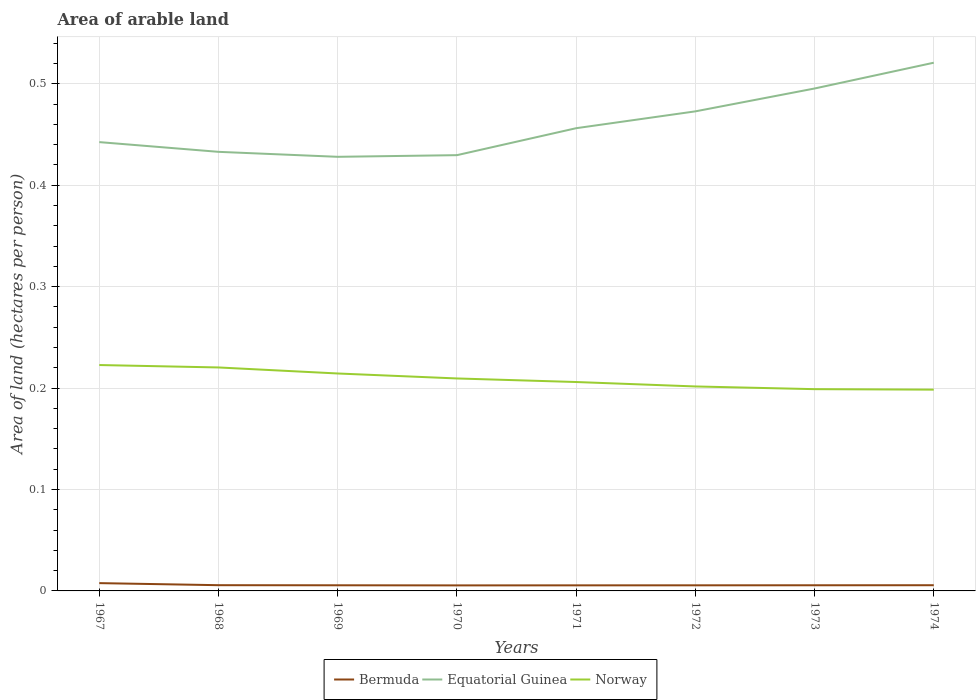How many different coloured lines are there?
Offer a very short reply. 3. Does the line corresponding to Norway intersect with the line corresponding to Equatorial Guinea?
Your answer should be compact. No. Across all years, what is the maximum total arable land in Norway?
Ensure brevity in your answer.  0.2. In which year was the total arable land in Equatorial Guinea maximum?
Offer a terse response. 1969. What is the total total arable land in Norway in the graph?
Offer a very short reply. 0.01. What is the difference between the highest and the second highest total arable land in Norway?
Your response must be concise. 0.02. Does the graph contain any zero values?
Make the answer very short. No. Does the graph contain grids?
Make the answer very short. Yes. How many legend labels are there?
Offer a very short reply. 3. How are the legend labels stacked?
Provide a succinct answer. Horizontal. What is the title of the graph?
Keep it short and to the point. Area of arable land. What is the label or title of the Y-axis?
Offer a terse response. Area of land (hectares per person). What is the Area of land (hectares per person) in Bermuda in 1967?
Provide a short and direct response. 0.01. What is the Area of land (hectares per person) of Equatorial Guinea in 1967?
Your answer should be very brief. 0.44. What is the Area of land (hectares per person) in Norway in 1967?
Keep it short and to the point. 0.22. What is the Area of land (hectares per person) in Bermuda in 1968?
Make the answer very short. 0.01. What is the Area of land (hectares per person) in Equatorial Guinea in 1968?
Offer a terse response. 0.43. What is the Area of land (hectares per person) of Norway in 1968?
Offer a terse response. 0.22. What is the Area of land (hectares per person) of Bermuda in 1969?
Offer a terse response. 0.01. What is the Area of land (hectares per person) of Equatorial Guinea in 1969?
Your answer should be compact. 0.43. What is the Area of land (hectares per person) of Norway in 1969?
Give a very brief answer. 0.21. What is the Area of land (hectares per person) in Bermuda in 1970?
Make the answer very short. 0.01. What is the Area of land (hectares per person) of Equatorial Guinea in 1970?
Provide a succinct answer. 0.43. What is the Area of land (hectares per person) of Norway in 1970?
Ensure brevity in your answer.  0.21. What is the Area of land (hectares per person) in Bermuda in 1971?
Give a very brief answer. 0.01. What is the Area of land (hectares per person) in Equatorial Guinea in 1971?
Provide a succinct answer. 0.46. What is the Area of land (hectares per person) of Norway in 1971?
Your response must be concise. 0.21. What is the Area of land (hectares per person) in Bermuda in 1972?
Keep it short and to the point. 0.01. What is the Area of land (hectares per person) in Equatorial Guinea in 1972?
Provide a succinct answer. 0.47. What is the Area of land (hectares per person) of Norway in 1972?
Ensure brevity in your answer.  0.2. What is the Area of land (hectares per person) in Bermuda in 1973?
Your answer should be very brief. 0.01. What is the Area of land (hectares per person) of Equatorial Guinea in 1973?
Keep it short and to the point. 0.5. What is the Area of land (hectares per person) of Norway in 1973?
Provide a short and direct response. 0.2. What is the Area of land (hectares per person) of Bermuda in 1974?
Provide a succinct answer. 0.01. What is the Area of land (hectares per person) of Equatorial Guinea in 1974?
Make the answer very short. 0.52. What is the Area of land (hectares per person) in Norway in 1974?
Your answer should be very brief. 0.2. Across all years, what is the maximum Area of land (hectares per person) in Bermuda?
Give a very brief answer. 0.01. Across all years, what is the maximum Area of land (hectares per person) of Equatorial Guinea?
Offer a terse response. 0.52. Across all years, what is the maximum Area of land (hectares per person) in Norway?
Provide a short and direct response. 0.22. Across all years, what is the minimum Area of land (hectares per person) in Bermuda?
Offer a terse response. 0.01. Across all years, what is the minimum Area of land (hectares per person) of Equatorial Guinea?
Provide a short and direct response. 0.43. Across all years, what is the minimum Area of land (hectares per person) of Norway?
Provide a succinct answer. 0.2. What is the total Area of land (hectares per person) of Bermuda in the graph?
Offer a terse response. 0.05. What is the total Area of land (hectares per person) of Equatorial Guinea in the graph?
Your answer should be very brief. 3.68. What is the total Area of land (hectares per person) of Norway in the graph?
Provide a short and direct response. 1.67. What is the difference between the Area of land (hectares per person) of Bermuda in 1967 and that in 1968?
Your answer should be very brief. 0. What is the difference between the Area of land (hectares per person) of Equatorial Guinea in 1967 and that in 1968?
Offer a very short reply. 0.01. What is the difference between the Area of land (hectares per person) of Norway in 1967 and that in 1968?
Your response must be concise. 0. What is the difference between the Area of land (hectares per person) in Bermuda in 1967 and that in 1969?
Provide a short and direct response. 0. What is the difference between the Area of land (hectares per person) in Equatorial Guinea in 1967 and that in 1969?
Give a very brief answer. 0.01. What is the difference between the Area of land (hectares per person) of Norway in 1967 and that in 1969?
Ensure brevity in your answer.  0.01. What is the difference between the Area of land (hectares per person) in Bermuda in 1967 and that in 1970?
Your answer should be very brief. 0. What is the difference between the Area of land (hectares per person) in Equatorial Guinea in 1967 and that in 1970?
Provide a succinct answer. 0.01. What is the difference between the Area of land (hectares per person) of Norway in 1967 and that in 1970?
Keep it short and to the point. 0.01. What is the difference between the Area of land (hectares per person) of Bermuda in 1967 and that in 1971?
Offer a very short reply. 0. What is the difference between the Area of land (hectares per person) in Equatorial Guinea in 1967 and that in 1971?
Offer a very short reply. -0.01. What is the difference between the Area of land (hectares per person) in Norway in 1967 and that in 1971?
Ensure brevity in your answer.  0.02. What is the difference between the Area of land (hectares per person) in Bermuda in 1967 and that in 1972?
Provide a succinct answer. 0. What is the difference between the Area of land (hectares per person) of Equatorial Guinea in 1967 and that in 1972?
Your answer should be compact. -0.03. What is the difference between the Area of land (hectares per person) of Norway in 1967 and that in 1972?
Give a very brief answer. 0.02. What is the difference between the Area of land (hectares per person) in Bermuda in 1967 and that in 1973?
Your answer should be very brief. 0. What is the difference between the Area of land (hectares per person) of Equatorial Guinea in 1967 and that in 1973?
Offer a very short reply. -0.05. What is the difference between the Area of land (hectares per person) of Norway in 1967 and that in 1973?
Make the answer very short. 0.02. What is the difference between the Area of land (hectares per person) of Bermuda in 1967 and that in 1974?
Offer a very short reply. 0. What is the difference between the Area of land (hectares per person) in Equatorial Guinea in 1967 and that in 1974?
Keep it short and to the point. -0.08. What is the difference between the Area of land (hectares per person) in Norway in 1967 and that in 1974?
Your answer should be very brief. 0.02. What is the difference between the Area of land (hectares per person) of Equatorial Guinea in 1968 and that in 1969?
Give a very brief answer. 0. What is the difference between the Area of land (hectares per person) of Norway in 1968 and that in 1969?
Give a very brief answer. 0.01. What is the difference between the Area of land (hectares per person) of Bermuda in 1968 and that in 1970?
Offer a very short reply. 0. What is the difference between the Area of land (hectares per person) of Equatorial Guinea in 1968 and that in 1970?
Your answer should be very brief. 0. What is the difference between the Area of land (hectares per person) of Norway in 1968 and that in 1970?
Your answer should be very brief. 0.01. What is the difference between the Area of land (hectares per person) in Bermuda in 1968 and that in 1971?
Keep it short and to the point. 0. What is the difference between the Area of land (hectares per person) of Equatorial Guinea in 1968 and that in 1971?
Your answer should be compact. -0.02. What is the difference between the Area of land (hectares per person) of Norway in 1968 and that in 1971?
Your answer should be compact. 0.01. What is the difference between the Area of land (hectares per person) in Bermuda in 1968 and that in 1972?
Make the answer very short. 0. What is the difference between the Area of land (hectares per person) of Equatorial Guinea in 1968 and that in 1972?
Your response must be concise. -0.04. What is the difference between the Area of land (hectares per person) of Norway in 1968 and that in 1972?
Give a very brief answer. 0.02. What is the difference between the Area of land (hectares per person) in Equatorial Guinea in 1968 and that in 1973?
Your response must be concise. -0.06. What is the difference between the Area of land (hectares per person) of Norway in 1968 and that in 1973?
Give a very brief answer. 0.02. What is the difference between the Area of land (hectares per person) in Bermuda in 1968 and that in 1974?
Provide a succinct answer. 0. What is the difference between the Area of land (hectares per person) in Equatorial Guinea in 1968 and that in 1974?
Make the answer very short. -0.09. What is the difference between the Area of land (hectares per person) in Norway in 1968 and that in 1974?
Your answer should be very brief. 0.02. What is the difference between the Area of land (hectares per person) in Bermuda in 1969 and that in 1970?
Give a very brief answer. 0. What is the difference between the Area of land (hectares per person) of Equatorial Guinea in 1969 and that in 1970?
Make the answer very short. -0. What is the difference between the Area of land (hectares per person) in Norway in 1969 and that in 1970?
Provide a short and direct response. 0. What is the difference between the Area of land (hectares per person) of Bermuda in 1969 and that in 1971?
Your response must be concise. 0. What is the difference between the Area of land (hectares per person) of Equatorial Guinea in 1969 and that in 1971?
Provide a short and direct response. -0.03. What is the difference between the Area of land (hectares per person) of Norway in 1969 and that in 1971?
Your response must be concise. 0.01. What is the difference between the Area of land (hectares per person) in Equatorial Guinea in 1969 and that in 1972?
Keep it short and to the point. -0.04. What is the difference between the Area of land (hectares per person) of Norway in 1969 and that in 1972?
Provide a short and direct response. 0.01. What is the difference between the Area of land (hectares per person) in Bermuda in 1969 and that in 1973?
Your response must be concise. -0. What is the difference between the Area of land (hectares per person) of Equatorial Guinea in 1969 and that in 1973?
Your answer should be very brief. -0.07. What is the difference between the Area of land (hectares per person) in Norway in 1969 and that in 1973?
Your answer should be very brief. 0.02. What is the difference between the Area of land (hectares per person) of Bermuda in 1969 and that in 1974?
Your answer should be very brief. -0. What is the difference between the Area of land (hectares per person) in Equatorial Guinea in 1969 and that in 1974?
Give a very brief answer. -0.09. What is the difference between the Area of land (hectares per person) of Norway in 1969 and that in 1974?
Provide a succinct answer. 0.02. What is the difference between the Area of land (hectares per person) of Equatorial Guinea in 1970 and that in 1971?
Your response must be concise. -0.03. What is the difference between the Area of land (hectares per person) of Norway in 1970 and that in 1971?
Give a very brief answer. 0. What is the difference between the Area of land (hectares per person) of Bermuda in 1970 and that in 1972?
Keep it short and to the point. -0. What is the difference between the Area of land (hectares per person) of Equatorial Guinea in 1970 and that in 1972?
Give a very brief answer. -0.04. What is the difference between the Area of land (hectares per person) in Norway in 1970 and that in 1972?
Your answer should be compact. 0.01. What is the difference between the Area of land (hectares per person) in Bermuda in 1970 and that in 1973?
Your answer should be compact. -0. What is the difference between the Area of land (hectares per person) of Equatorial Guinea in 1970 and that in 1973?
Ensure brevity in your answer.  -0.07. What is the difference between the Area of land (hectares per person) of Norway in 1970 and that in 1973?
Your response must be concise. 0.01. What is the difference between the Area of land (hectares per person) of Bermuda in 1970 and that in 1974?
Provide a short and direct response. -0. What is the difference between the Area of land (hectares per person) in Equatorial Guinea in 1970 and that in 1974?
Provide a succinct answer. -0.09. What is the difference between the Area of land (hectares per person) of Norway in 1970 and that in 1974?
Give a very brief answer. 0.01. What is the difference between the Area of land (hectares per person) in Equatorial Guinea in 1971 and that in 1972?
Your response must be concise. -0.02. What is the difference between the Area of land (hectares per person) of Norway in 1971 and that in 1972?
Offer a very short reply. 0. What is the difference between the Area of land (hectares per person) in Bermuda in 1971 and that in 1973?
Keep it short and to the point. -0. What is the difference between the Area of land (hectares per person) in Equatorial Guinea in 1971 and that in 1973?
Make the answer very short. -0.04. What is the difference between the Area of land (hectares per person) in Norway in 1971 and that in 1973?
Provide a succinct answer. 0.01. What is the difference between the Area of land (hectares per person) in Bermuda in 1971 and that in 1974?
Your response must be concise. -0. What is the difference between the Area of land (hectares per person) of Equatorial Guinea in 1971 and that in 1974?
Provide a short and direct response. -0.06. What is the difference between the Area of land (hectares per person) in Norway in 1971 and that in 1974?
Your answer should be compact. 0.01. What is the difference between the Area of land (hectares per person) of Bermuda in 1972 and that in 1973?
Give a very brief answer. -0. What is the difference between the Area of land (hectares per person) in Equatorial Guinea in 1972 and that in 1973?
Offer a terse response. -0.02. What is the difference between the Area of land (hectares per person) in Norway in 1972 and that in 1973?
Ensure brevity in your answer.  0. What is the difference between the Area of land (hectares per person) in Bermuda in 1972 and that in 1974?
Offer a terse response. -0. What is the difference between the Area of land (hectares per person) of Equatorial Guinea in 1972 and that in 1974?
Make the answer very short. -0.05. What is the difference between the Area of land (hectares per person) in Norway in 1972 and that in 1974?
Provide a succinct answer. 0. What is the difference between the Area of land (hectares per person) in Equatorial Guinea in 1973 and that in 1974?
Your response must be concise. -0.03. What is the difference between the Area of land (hectares per person) in Norway in 1973 and that in 1974?
Provide a succinct answer. 0. What is the difference between the Area of land (hectares per person) in Bermuda in 1967 and the Area of land (hectares per person) in Equatorial Guinea in 1968?
Offer a terse response. -0.43. What is the difference between the Area of land (hectares per person) of Bermuda in 1967 and the Area of land (hectares per person) of Norway in 1968?
Provide a succinct answer. -0.21. What is the difference between the Area of land (hectares per person) of Equatorial Guinea in 1967 and the Area of land (hectares per person) of Norway in 1968?
Provide a short and direct response. 0.22. What is the difference between the Area of land (hectares per person) of Bermuda in 1967 and the Area of land (hectares per person) of Equatorial Guinea in 1969?
Keep it short and to the point. -0.42. What is the difference between the Area of land (hectares per person) of Bermuda in 1967 and the Area of land (hectares per person) of Norway in 1969?
Keep it short and to the point. -0.21. What is the difference between the Area of land (hectares per person) of Equatorial Guinea in 1967 and the Area of land (hectares per person) of Norway in 1969?
Offer a very short reply. 0.23. What is the difference between the Area of land (hectares per person) of Bermuda in 1967 and the Area of land (hectares per person) of Equatorial Guinea in 1970?
Offer a very short reply. -0.42. What is the difference between the Area of land (hectares per person) of Bermuda in 1967 and the Area of land (hectares per person) of Norway in 1970?
Your answer should be compact. -0.2. What is the difference between the Area of land (hectares per person) in Equatorial Guinea in 1967 and the Area of land (hectares per person) in Norway in 1970?
Your response must be concise. 0.23. What is the difference between the Area of land (hectares per person) of Bermuda in 1967 and the Area of land (hectares per person) of Equatorial Guinea in 1971?
Ensure brevity in your answer.  -0.45. What is the difference between the Area of land (hectares per person) in Bermuda in 1967 and the Area of land (hectares per person) in Norway in 1971?
Provide a short and direct response. -0.2. What is the difference between the Area of land (hectares per person) in Equatorial Guinea in 1967 and the Area of land (hectares per person) in Norway in 1971?
Offer a very short reply. 0.24. What is the difference between the Area of land (hectares per person) of Bermuda in 1967 and the Area of land (hectares per person) of Equatorial Guinea in 1972?
Provide a short and direct response. -0.47. What is the difference between the Area of land (hectares per person) in Bermuda in 1967 and the Area of land (hectares per person) in Norway in 1972?
Make the answer very short. -0.19. What is the difference between the Area of land (hectares per person) of Equatorial Guinea in 1967 and the Area of land (hectares per person) of Norway in 1972?
Make the answer very short. 0.24. What is the difference between the Area of land (hectares per person) in Bermuda in 1967 and the Area of land (hectares per person) in Equatorial Guinea in 1973?
Your answer should be compact. -0.49. What is the difference between the Area of land (hectares per person) of Bermuda in 1967 and the Area of land (hectares per person) of Norway in 1973?
Offer a very short reply. -0.19. What is the difference between the Area of land (hectares per person) of Equatorial Guinea in 1967 and the Area of land (hectares per person) of Norway in 1973?
Keep it short and to the point. 0.24. What is the difference between the Area of land (hectares per person) of Bermuda in 1967 and the Area of land (hectares per person) of Equatorial Guinea in 1974?
Give a very brief answer. -0.51. What is the difference between the Area of land (hectares per person) of Bermuda in 1967 and the Area of land (hectares per person) of Norway in 1974?
Provide a short and direct response. -0.19. What is the difference between the Area of land (hectares per person) of Equatorial Guinea in 1967 and the Area of land (hectares per person) of Norway in 1974?
Your answer should be very brief. 0.24. What is the difference between the Area of land (hectares per person) of Bermuda in 1968 and the Area of land (hectares per person) of Equatorial Guinea in 1969?
Offer a terse response. -0.42. What is the difference between the Area of land (hectares per person) in Bermuda in 1968 and the Area of land (hectares per person) in Norway in 1969?
Provide a short and direct response. -0.21. What is the difference between the Area of land (hectares per person) in Equatorial Guinea in 1968 and the Area of land (hectares per person) in Norway in 1969?
Make the answer very short. 0.22. What is the difference between the Area of land (hectares per person) of Bermuda in 1968 and the Area of land (hectares per person) of Equatorial Guinea in 1970?
Provide a short and direct response. -0.42. What is the difference between the Area of land (hectares per person) in Bermuda in 1968 and the Area of land (hectares per person) in Norway in 1970?
Your answer should be compact. -0.2. What is the difference between the Area of land (hectares per person) in Equatorial Guinea in 1968 and the Area of land (hectares per person) in Norway in 1970?
Make the answer very short. 0.22. What is the difference between the Area of land (hectares per person) of Bermuda in 1968 and the Area of land (hectares per person) of Equatorial Guinea in 1971?
Ensure brevity in your answer.  -0.45. What is the difference between the Area of land (hectares per person) of Bermuda in 1968 and the Area of land (hectares per person) of Norway in 1971?
Give a very brief answer. -0.2. What is the difference between the Area of land (hectares per person) in Equatorial Guinea in 1968 and the Area of land (hectares per person) in Norway in 1971?
Give a very brief answer. 0.23. What is the difference between the Area of land (hectares per person) in Bermuda in 1968 and the Area of land (hectares per person) in Equatorial Guinea in 1972?
Provide a short and direct response. -0.47. What is the difference between the Area of land (hectares per person) of Bermuda in 1968 and the Area of land (hectares per person) of Norway in 1972?
Ensure brevity in your answer.  -0.2. What is the difference between the Area of land (hectares per person) in Equatorial Guinea in 1968 and the Area of land (hectares per person) in Norway in 1972?
Keep it short and to the point. 0.23. What is the difference between the Area of land (hectares per person) in Bermuda in 1968 and the Area of land (hectares per person) in Equatorial Guinea in 1973?
Give a very brief answer. -0.49. What is the difference between the Area of land (hectares per person) of Bermuda in 1968 and the Area of land (hectares per person) of Norway in 1973?
Provide a succinct answer. -0.19. What is the difference between the Area of land (hectares per person) of Equatorial Guinea in 1968 and the Area of land (hectares per person) of Norway in 1973?
Make the answer very short. 0.23. What is the difference between the Area of land (hectares per person) of Bermuda in 1968 and the Area of land (hectares per person) of Equatorial Guinea in 1974?
Your answer should be very brief. -0.52. What is the difference between the Area of land (hectares per person) of Bermuda in 1968 and the Area of land (hectares per person) of Norway in 1974?
Offer a terse response. -0.19. What is the difference between the Area of land (hectares per person) in Equatorial Guinea in 1968 and the Area of land (hectares per person) in Norway in 1974?
Offer a very short reply. 0.23. What is the difference between the Area of land (hectares per person) in Bermuda in 1969 and the Area of land (hectares per person) in Equatorial Guinea in 1970?
Provide a short and direct response. -0.42. What is the difference between the Area of land (hectares per person) of Bermuda in 1969 and the Area of land (hectares per person) of Norway in 1970?
Provide a succinct answer. -0.2. What is the difference between the Area of land (hectares per person) of Equatorial Guinea in 1969 and the Area of land (hectares per person) of Norway in 1970?
Your answer should be very brief. 0.22. What is the difference between the Area of land (hectares per person) in Bermuda in 1969 and the Area of land (hectares per person) in Equatorial Guinea in 1971?
Your answer should be very brief. -0.45. What is the difference between the Area of land (hectares per person) of Bermuda in 1969 and the Area of land (hectares per person) of Norway in 1971?
Your answer should be very brief. -0.2. What is the difference between the Area of land (hectares per person) in Equatorial Guinea in 1969 and the Area of land (hectares per person) in Norway in 1971?
Keep it short and to the point. 0.22. What is the difference between the Area of land (hectares per person) of Bermuda in 1969 and the Area of land (hectares per person) of Equatorial Guinea in 1972?
Give a very brief answer. -0.47. What is the difference between the Area of land (hectares per person) of Bermuda in 1969 and the Area of land (hectares per person) of Norway in 1972?
Your answer should be compact. -0.2. What is the difference between the Area of land (hectares per person) of Equatorial Guinea in 1969 and the Area of land (hectares per person) of Norway in 1972?
Offer a terse response. 0.23. What is the difference between the Area of land (hectares per person) in Bermuda in 1969 and the Area of land (hectares per person) in Equatorial Guinea in 1973?
Your answer should be compact. -0.49. What is the difference between the Area of land (hectares per person) in Bermuda in 1969 and the Area of land (hectares per person) in Norway in 1973?
Make the answer very short. -0.19. What is the difference between the Area of land (hectares per person) of Equatorial Guinea in 1969 and the Area of land (hectares per person) of Norway in 1973?
Provide a short and direct response. 0.23. What is the difference between the Area of land (hectares per person) of Bermuda in 1969 and the Area of land (hectares per person) of Equatorial Guinea in 1974?
Keep it short and to the point. -0.52. What is the difference between the Area of land (hectares per person) in Bermuda in 1969 and the Area of land (hectares per person) in Norway in 1974?
Provide a short and direct response. -0.19. What is the difference between the Area of land (hectares per person) in Equatorial Guinea in 1969 and the Area of land (hectares per person) in Norway in 1974?
Keep it short and to the point. 0.23. What is the difference between the Area of land (hectares per person) of Bermuda in 1970 and the Area of land (hectares per person) of Equatorial Guinea in 1971?
Your answer should be compact. -0.45. What is the difference between the Area of land (hectares per person) of Bermuda in 1970 and the Area of land (hectares per person) of Norway in 1971?
Your answer should be compact. -0.2. What is the difference between the Area of land (hectares per person) of Equatorial Guinea in 1970 and the Area of land (hectares per person) of Norway in 1971?
Offer a terse response. 0.22. What is the difference between the Area of land (hectares per person) of Bermuda in 1970 and the Area of land (hectares per person) of Equatorial Guinea in 1972?
Offer a very short reply. -0.47. What is the difference between the Area of land (hectares per person) in Bermuda in 1970 and the Area of land (hectares per person) in Norway in 1972?
Your answer should be very brief. -0.2. What is the difference between the Area of land (hectares per person) in Equatorial Guinea in 1970 and the Area of land (hectares per person) in Norway in 1972?
Offer a very short reply. 0.23. What is the difference between the Area of land (hectares per person) in Bermuda in 1970 and the Area of land (hectares per person) in Equatorial Guinea in 1973?
Your response must be concise. -0.49. What is the difference between the Area of land (hectares per person) in Bermuda in 1970 and the Area of land (hectares per person) in Norway in 1973?
Offer a very short reply. -0.19. What is the difference between the Area of land (hectares per person) of Equatorial Guinea in 1970 and the Area of land (hectares per person) of Norway in 1973?
Make the answer very short. 0.23. What is the difference between the Area of land (hectares per person) in Bermuda in 1970 and the Area of land (hectares per person) in Equatorial Guinea in 1974?
Offer a terse response. -0.52. What is the difference between the Area of land (hectares per person) of Bermuda in 1970 and the Area of land (hectares per person) of Norway in 1974?
Offer a very short reply. -0.19. What is the difference between the Area of land (hectares per person) in Equatorial Guinea in 1970 and the Area of land (hectares per person) in Norway in 1974?
Your response must be concise. 0.23. What is the difference between the Area of land (hectares per person) of Bermuda in 1971 and the Area of land (hectares per person) of Equatorial Guinea in 1972?
Offer a very short reply. -0.47. What is the difference between the Area of land (hectares per person) in Bermuda in 1971 and the Area of land (hectares per person) in Norway in 1972?
Provide a short and direct response. -0.2. What is the difference between the Area of land (hectares per person) in Equatorial Guinea in 1971 and the Area of land (hectares per person) in Norway in 1972?
Offer a very short reply. 0.25. What is the difference between the Area of land (hectares per person) in Bermuda in 1971 and the Area of land (hectares per person) in Equatorial Guinea in 1973?
Your answer should be very brief. -0.49. What is the difference between the Area of land (hectares per person) in Bermuda in 1971 and the Area of land (hectares per person) in Norway in 1973?
Offer a terse response. -0.19. What is the difference between the Area of land (hectares per person) in Equatorial Guinea in 1971 and the Area of land (hectares per person) in Norway in 1973?
Your response must be concise. 0.26. What is the difference between the Area of land (hectares per person) of Bermuda in 1971 and the Area of land (hectares per person) of Equatorial Guinea in 1974?
Offer a terse response. -0.52. What is the difference between the Area of land (hectares per person) of Bermuda in 1971 and the Area of land (hectares per person) of Norway in 1974?
Offer a terse response. -0.19. What is the difference between the Area of land (hectares per person) in Equatorial Guinea in 1971 and the Area of land (hectares per person) in Norway in 1974?
Offer a very short reply. 0.26. What is the difference between the Area of land (hectares per person) in Bermuda in 1972 and the Area of land (hectares per person) in Equatorial Guinea in 1973?
Keep it short and to the point. -0.49. What is the difference between the Area of land (hectares per person) of Bermuda in 1972 and the Area of land (hectares per person) of Norway in 1973?
Ensure brevity in your answer.  -0.19. What is the difference between the Area of land (hectares per person) of Equatorial Guinea in 1972 and the Area of land (hectares per person) of Norway in 1973?
Ensure brevity in your answer.  0.27. What is the difference between the Area of land (hectares per person) of Bermuda in 1972 and the Area of land (hectares per person) of Equatorial Guinea in 1974?
Make the answer very short. -0.52. What is the difference between the Area of land (hectares per person) in Bermuda in 1972 and the Area of land (hectares per person) in Norway in 1974?
Make the answer very short. -0.19. What is the difference between the Area of land (hectares per person) of Equatorial Guinea in 1972 and the Area of land (hectares per person) of Norway in 1974?
Offer a terse response. 0.27. What is the difference between the Area of land (hectares per person) of Bermuda in 1973 and the Area of land (hectares per person) of Equatorial Guinea in 1974?
Give a very brief answer. -0.52. What is the difference between the Area of land (hectares per person) of Bermuda in 1973 and the Area of land (hectares per person) of Norway in 1974?
Give a very brief answer. -0.19. What is the difference between the Area of land (hectares per person) in Equatorial Guinea in 1973 and the Area of land (hectares per person) in Norway in 1974?
Give a very brief answer. 0.3. What is the average Area of land (hectares per person) in Bermuda per year?
Your answer should be very brief. 0.01. What is the average Area of land (hectares per person) of Equatorial Guinea per year?
Offer a very short reply. 0.46. What is the average Area of land (hectares per person) in Norway per year?
Your response must be concise. 0.21. In the year 1967, what is the difference between the Area of land (hectares per person) of Bermuda and Area of land (hectares per person) of Equatorial Guinea?
Provide a succinct answer. -0.43. In the year 1967, what is the difference between the Area of land (hectares per person) of Bermuda and Area of land (hectares per person) of Norway?
Offer a terse response. -0.22. In the year 1967, what is the difference between the Area of land (hectares per person) of Equatorial Guinea and Area of land (hectares per person) of Norway?
Make the answer very short. 0.22. In the year 1968, what is the difference between the Area of land (hectares per person) in Bermuda and Area of land (hectares per person) in Equatorial Guinea?
Your response must be concise. -0.43. In the year 1968, what is the difference between the Area of land (hectares per person) in Bermuda and Area of land (hectares per person) in Norway?
Offer a terse response. -0.21. In the year 1968, what is the difference between the Area of land (hectares per person) in Equatorial Guinea and Area of land (hectares per person) in Norway?
Your answer should be compact. 0.21. In the year 1969, what is the difference between the Area of land (hectares per person) in Bermuda and Area of land (hectares per person) in Equatorial Guinea?
Your response must be concise. -0.42. In the year 1969, what is the difference between the Area of land (hectares per person) in Bermuda and Area of land (hectares per person) in Norway?
Provide a short and direct response. -0.21. In the year 1969, what is the difference between the Area of land (hectares per person) in Equatorial Guinea and Area of land (hectares per person) in Norway?
Give a very brief answer. 0.21. In the year 1970, what is the difference between the Area of land (hectares per person) in Bermuda and Area of land (hectares per person) in Equatorial Guinea?
Offer a terse response. -0.42. In the year 1970, what is the difference between the Area of land (hectares per person) in Bermuda and Area of land (hectares per person) in Norway?
Make the answer very short. -0.2. In the year 1970, what is the difference between the Area of land (hectares per person) of Equatorial Guinea and Area of land (hectares per person) of Norway?
Offer a terse response. 0.22. In the year 1971, what is the difference between the Area of land (hectares per person) of Bermuda and Area of land (hectares per person) of Equatorial Guinea?
Your response must be concise. -0.45. In the year 1971, what is the difference between the Area of land (hectares per person) of Bermuda and Area of land (hectares per person) of Norway?
Offer a terse response. -0.2. In the year 1971, what is the difference between the Area of land (hectares per person) of Equatorial Guinea and Area of land (hectares per person) of Norway?
Keep it short and to the point. 0.25. In the year 1972, what is the difference between the Area of land (hectares per person) in Bermuda and Area of land (hectares per person) in Equatorial Guinea?
Keep it short and to the point. -0.47. In the year 1972, what is the difference between the Area of land (hectares per person) in Bermuda and Area of land (hectares per person) in Norway?
Make the answer very short. -0.2. In the year 1972, what is the difference between the Area of land (hectares per person) in Equatorial Guinea and Area of land (hectares per person) in Norway?
Offer a terse response. 0.27. In the year 1973, what is the difference between the Area of land (hectares per person) in Bermuda and Area of land (hectares per person) in Equatorial Guinea?
Provide a short and direct response. -0.49. In the year 1973, what is the difference between the Area of land (hectares per person) of Bermuda and Area of land (hectares per person) of Norway?
Make the answer very short. -0.19. In the year 1973, what is the difference between the Area of land (hectares per person) in Equatorial Guinea and Area of land (hectares per person) in Norway?
Your response must be concise. 0.3. In the year 1974, what is the difference between the Area of land (hectares per person) of Bermuda and Area of land (hectares per person) of Equatorial Guinea?
Provide a succinct answer. -0.52. In the year 1974, what is the difference between the Area of land (hectares per person) of Bermuda and Area of land (hectares per person) of Norway?
Give a very brief answer. -0.19. In the year 1974, what is the difference between the Area of land (hectares per person) in Equatorial Guinea and Area of land (hectares per person) in Norway?
Give a very brief answer. 0.32. What is the ratio of the Area of land (hectares per person) in Bermuda in 1967 to that in 1968?
Provide a succinct answer. 1.36. What is the ratio of the Area of land (hectares per person) in Equatorial Guinea in 1967 to that in 1968?
Your answer should be compact. 1.02. What is the ratio of the Area of land (hectares per person) in Norway in 1967 to that in 1968?
Your answer should be compact. 1.01. What is the ratio of the Area of land (hectares per person) in Bermuda in 1967 to that in 1969?
Offer a terse response. 1.38. What is the ratio of the Area of land (hectares per person) in Equatorial Guinea in 1967 to that in 1969?
Your answer should be very brief. 1.03. What is the ratio of the Area of land (hectares per person) in Norway in 1967 to that in 1969?
Your answer should be very brief. 1.04. What is the ratio of the Area of land (hectares per person) in Bermuda in 1967 to that in 1970?
Offer a very short reply. 1.41. What is the ratio of the Area of land (hectares per person) in Equatorial Guinea in 1967 to that in 1970?
Make the answer very short. 1.03. What is the ratio of the Area of land (hectares per person) in Norway in 1967 to that in 1970?
Your answer should be compact. 1.06. What is the ratio of the Area of land (hectares per person) of Bermuda in 1967 to that in 1971?
Keep it short and to the point. 1.4. What is the ratio of the Area of land (hectares per person) of Equatorial Guinea in 1967 to that in 1971?
Give a very brief answer. 0.97. What is the ratio of the Area of land (hectares per person) in Norway in 1967 to that in 1971?
Keep it short and to the point. 1.08. What is the ratio of the Area of land (hectares per person) in Bermuda in 1967 to that in 1972?
Provide a short and direct response. 1.39. What is the ratio of the Area of land (hectares per person) in Equatorial Guinea in 1967 to that in 1972?
Provide a short and direct response. 0.94. What is the ratio of the Area of land (hectares per person) in Norway in 1967 to that in 1972?
Keep it short and to the point. 1.1. What is the ratio of the Area of land (hectares per person) of Bermuda in 1967 to that in 1973?
Offer a terse response. 1.38. What is the ratio of the Area of land (hectares per person) in Equatorial Guinea in 1967 to that in 1973?
Give a very brief answer. 0.89. What is the ratio of the Area of land (hectares per person) in Norway in 1967 to that in 1973?
Your answer should be very brief. 1.12. What is the ratio of the Area of land (hectares per person) in Bermuda in 1967 to that in 1974?
Your answer should be compact. 1.37. What is the ratio of the Area of land (hectares per person) of Equatorial Guinea in 1967 to that in 1974?
Provide a short and direct response. 0.85. What is the ratio of the Area of land (hectares per person) of Norway in 1967 to that in 1974?
Keep it short and to the point. 1.12. What is the ratio of the Area of land (hectares per person) in Bermuda in 1968 to that in 1969?
Ensure brevity in your answer.  1.02. What is the ratio of the Area of land (hectares per person) of Equatorial Guinea in 1968 to that in 1969?
Make the answer very short. 1.01. What is the ratio of the Area of land (hectares per person) of Norway in 1968 to that in 1969?
Provide a short and direct response. 1.03. What is the ratio of the Area of land (hectares per person) in Bermuda in 1968 to that in 1970?
Your response must be concise. 1.04. What is the ratio of the Area of land (hectares per person) in Equatorial Guinea in 1968 to that in 1970?
Your response must be concise. 1.01. What is the ratio of the Area of land (hectares per person) of Norway in 1968 to that in 1970?
Offer a terse response. 1.05. What is the ratio of the Area of land (hectares per person) of Bermuda in 1968 to that in 1971?
Your answer should be compact. 1.03. What is the ratio of the Area of land (hectares per person) in Equatorial Guinea in 1968 to that in 1971?
Your answer should be compact. 0.95. What is the ratio of the Area of land (hectares per person) in Norway in 1968 to that in 1971?
Your response must be concise. 1.07. What is the ratio of the Area of land (hectares per person) of Bermuda in 1968 to that in 1972?
Provide a short and direct response. 1.02. What is the ratio of the Area of land (hectares per person) of Equatorial Guinea in 1968 to that in 1972?
Give a very brief answer. 0.92. What is the ratio of the Area of land (hectares per person) of Norway in 1968 to that in 1972?
Make the answer very short. 1.09. What is the ratio of the Area of land (hectares per person) of Bermuda in 1968 to that in 1973?
Give a very brief answer. 1.02. What is the ratio of the Area of land (hectares per person) in Equatorial Guinea in 1968 to that in 1973?
Provide a short and direct response. 0.87. What is the ratio of the Area of land (hectares per person) of Norway in 1968 to that in 1973?
Make the answer very short. 1.11. What is the ratio of the Area of land (hectares per person) in Bermuda in 1968 to that in 1974?
Keep it short and to the point. 1.01. What is the ratio of the Area of land (hectares per person) of Equatorial Guinea in 1968 to that in 1974?
Your answer should be compact. 0.83. What is the ratio of the Area of land (hectares per person) of Norway in 1968 to that in 1974?
Offer a very short reply. 1.11. What is the ratio of the Area of land (hectares per person) of Bermuda in 1969 to that in 1970?
Offer a very short reply. 1.02. What is the ratio of the Area of land (hectares per person) of Norway in 1969 to that in 1970?
Provide a short and direct response. 1.02. What is the ratio of the Area of land (hectares per person) of Bermuda in 1969 to that in 1971?
Give a very brief answer. 1.01. What is the ratio of the Area of land (hectares per person) of Equatorial Guinea in 1969 to that in 1971?
Your answer should be very brief. 0.94. What is the ratio of the Area of land (hectares per person) of Norway in 1969 to that in 1971?
Provide a succinct answer. 1.04. What is the ratio of the Area of land (hectares per person) in Bermuda in 1969 to that in 1972?
Give a very brief answer. 1. What is the ratio of the Area of land (hectares per person) in Equatorial Guinea in 1969 to that in 1972?
Your response must be concise. 0.91. What is the ratio of the Area of land (hectares per person) in Norway in 1969 to that in 1972?
Offer a very short reply. 1.06. What is the ratio of the Area of land (hectares per person) of Equatorial Guinea in 1969 to that in 1973?
Your answer should be compact. 0.86. What is the ratio of the Area of land (hectares per person) in Norway in 1969 to that in 1973?
Provide a succinct answer. 1.08. What is the ratio of the Area of land (hectares per person) in Bermuda in 1969 to that in 1974?
Your answer should be very brief. 0.99. What is the ratio of the Area of land (hectares per person) of Equatorial Guinea in 1969 to that in 1974?
Give a very brief answer. 0.82. What is the ratio of the Area of land (hectares per person) in Norway in 1969 to that in 1974?
Offer a terse response. 1.08. What is the ratio of the Area of land (hectares per person) of Bermuda in 1970 to that in 1971?
Keep it short and to the point. 0.99. What is the ratio of the Area of land (hectares per person) of Equatorial Guinea in 1970 to that in 1971?
Your answer should be compact. 0.94. What is the ratio of the Area of land (hectares per person) in Norway in 1970 to that in 1971?
Ensure brevity in your answer.  1.02. What is the ratio of the Area of land (hectares per person) of Bermuda in 1970 to that in 1972?
Your answer should be compact. 0.99. What is the ratio of the Area of land (hectares per person) in Equatorial Guinea in 1970 to that in 1972?
Provide a succinct answer. 0.91. What is the ratio of the Area of land (hectares per person) of Norway in 1970 to that in 1972?
Your answer should be compact. 1.04. What is the ratio of the Area of land (hectares per person) of Bermuda in 1970 to that in 1973?
Your answer should be compact. 0.98. What is the ratio of the Area of land (hectares per person) in Equatorial Guinea in 1970 to that in 1973?
Keep it short and to the point. 0.87. What is the ratio of the Area of land (hectares per person) in Norway in 1970 to that in 1973?
Give a very brief answer. 1.05. What is the ratio of the Area of land (hectares per person) in Bermuda in 1970 to that in 1974?
Give a very brief answer. 0.97. What is the ratio of the Area of land (hectares per person) in Equatorial Guinea in 1970 to that in 1974?
Offer a terse response. 0.82. What is the ratio of the Area of land (hectares per person) in Norway in 1970 to that in 1974?
Keep it short and to the point. 1.06. What is the ratio of the Area of land (hectares per person) of Bermuda in 1971 to that in 1972?
Provide a succinct answer. 0.99. What is the ratio of the Area of land (hectares per person) in Equatorial Guinea in 1971 to that in 1972?
Your answer should be very brief. 0.96. What is the ratio of the Area of land (hectares per person) of Norway in 1971 to that in 1972?
Your answer should be very brief. 1.02. What is the ratio of the Area of land (hectares per person) of Bermuda in 1971 to that in 1973?
Give a very brief answer. 0.99. What is the ratio of the Area of land (hectares per person) in Equatorial Guinea in 1971 to that in 1973?
Provide a succinct answer. 0.92. What is the ratio of the Area of land (hectares per person) in Norway in 1971 to that in 1973?
Keep it short and to the point. 1.04. What is the ratio of the Area of land (hectares per person) of Bermuda in 1971 to that in 1974?
Your answer should be compact. 0.98. What is the ratio of the Area of land (hectares per person) of Equatorial Guinea in 1971 to that in 1974?
Offer a terse response. 0.88. What is the ratio of the Area of land (hectares per person) of Norway in 1971 to that in 1974?
Keep it short and to the point. 1.04. What is the ratio of the Area of land (hectares per person) of Bermuda in 1972 to that in 1973?
Make the answer very short. 0.99. What is the ratio of the Area of land (hectares per person) in Equatorial Guinea in 1972 to that in 1973?
Offer a very short reply. 0.95. What is the ratio of the Area of land (hectares per person) in Norway in 1972 to that in 1973?
Provide a succinct answer. 1.01. What is the ratio of the Area of land (hectares per person) of Bermuda in 1972 to that in 1974?
Your answer should be compact. 0.99. What is the ratio of the Area of land (hectares per person) in Equatorial Guinea in 1972 to that in 1974?
Your answer should be very brief. 0.91. What is the ratio of the Area of land (hectares per person) in Norway in 1972 to that in 1974?
Provide a short and direct response. 1.02. What is the ratio of the Area of land (hectares per person) of Bermuda in 1973 to that in 1974?
Give a very brief answer. 0.99. What is the ratio of the Area of land (hectares per person) in Equatorial Guinea in 1973 to that in 1974?
Your answer should be very brief. 0.95. What is the difference between the highest and the second highest Area of land (hectares per person) of Bermuda?
Offer a terse response. 0. What is the difference between the highest and the second highest Area of land (hectares per person) in Equatorial Guinea?
Your answer should be very brief. 0.03. What is the difference between the highest and the second highest Area of land (hectares per person) in Norway?
Your answer should be compact. 0. What is the difference between the highest and the lowest Area of land (hectares per person) in Bermuda?
Keep it short and to the point. 0. What is the difference between the highest and the lowest Area of land (hectares per person) in Equatorial Guinea?
Your answer should be compact. 0.09. What is the difference between the highest and the lowest Area of land (hectares per person) in Norway?
Offer a terse response. 0.02. 